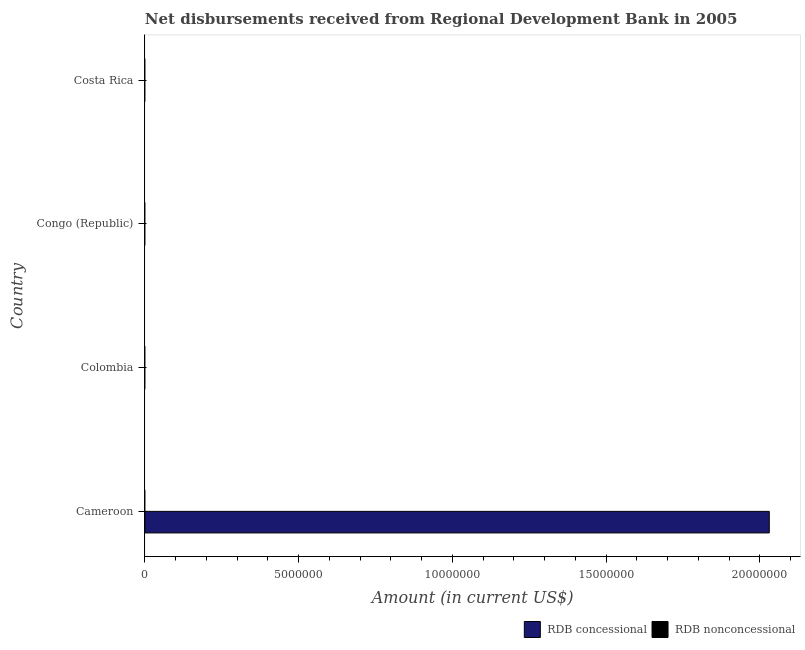Are the number of bars per tick equal to the number of legend labels?
Offer a terse response. No. How many bars are there on the 4th tick from the bottom?
Offer a terse response. 0. What is the label of the 4th group of bars from the top?
Provide a succinct answer. Cameroon. In how many cases, is the number of bars for a given country not equal to the number of legend labels?
Your response must be concise. 4. In which country was the net concessional disbursements from rdb maximum?
Your answer should be very brief. Cameroon. What is the difference between the net concessional disbursements from rdb in Cameroon and the net non concessional disbursements from rdb in Colombia?
Offer a terse response. 2.03e+07. What is the average net non concessional disbursements from rdb per country?
Your answer should be compact. 0. In how many countries, is the net non concessional disbursements from rdb greater than 18000000 US$?
Make the answer very short. 0. What is the difference between the highest and the lowest net concessional disbursements from rdb?
Provide a short and direct response. 2.03e+07. In how many countries, is the net concessional disbursements from rdb greater than the average net concessional disbursements from rdb taken over all countries?
Keep it short and to the point. 1. How many bars are there?
Keep it short and to the point. 1. What is the difference between two consecutive major ticks on the X-axis?
Provide a short and direct response. 5.00e+06. Are the values on the major ticks of X-axis written in scientific E-notation?
Keep it short and to the point. No. Does the graph contain any zero values?
Your answer should be compact. Yes. Where does the legend appear in the graph?
Your response must be concise. Bottom right. How many legend labels are there?
Provide a short and direct response. 2. What is the title of the graph?
Offer a terse response. Net disbursements received from Regional Development Bank in 2005. What is the label or title of the X-axis?
Keep it short and to the point. Amount (in current US$). What is the label or title of the Y-axis?
Ensure brevity in your answer.  Country. What is the Amount (in current US$) of RDB concessional in Cameroon?
Your answer should be compact. 2.03e+07. What is the Amount (in current US$) of RDB nonconcessional in Colombia?
Ensure brevity in your answer.  0. What is the Amount (in current US$) in RDB concessional in Congo (Republic)?
Ensure brevity in your answer.  0. What is the Amount (in current US$) in RDB concessional in Costa Rica?
Provide a succinct answer. 0. What is the Amount (in current US$) in RDB nonconcessional in Costa Rica?
Provide a succinct answer. 0. Across all countries, what is the maximum Amount (in current US$) in RDB concessional?
Provide a succinct answer. 2.03e+07. Across all countries, what is the minimum Amount (in current US$) of RDB concessional?
Your answer should be compact. 0. What is the total Amount (in current US$) of RDB concessional in the graph?
Your answer should be very brief. 2.03e+07. What is the average Amount (in current US$) in RDB concessional per country?
Offer a very short reply. 5.08e+06. What is the difference between the highest and the lowest Amount (in current US$) in RDB concessional?
Provide a short and direct response. 2.03e+07. 